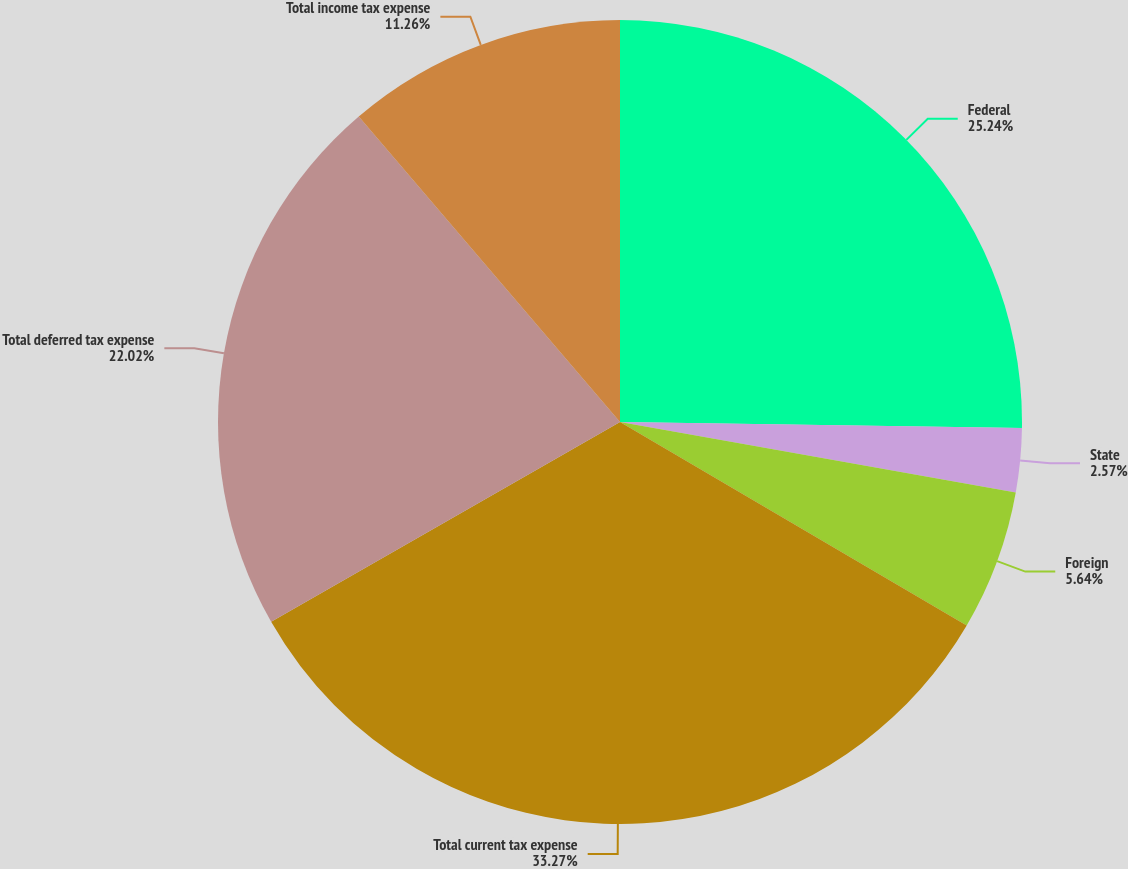Convert chart. <chart><loc_0><loc_0><loc_500><loc_500><pie_chart><fcel>Federal<fcel>State<fcel>Foreign<fcel>Total current tax expense<fcel>Total deferred tax expense<fcel>Total income tax expense<nl><fcel>25.24%<fcel>2.57%<fcel>5.64%<fcel>33.28%<fcel>22.02%<fcel>11.26%<nl></chart> 